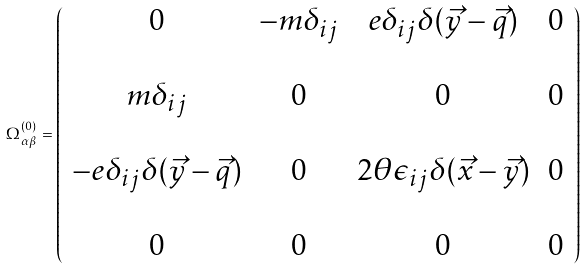Convert formula to latex. <formula><loc_0><loc_0><loc_500><loc_500>\Omega ^ { ( 0 ) } _ { \alpha \beta } = \left ( \begin{array} { c c c c } 0 & - m \delta _ { i j } & e \delta _ { i j } \delta ( \vec { y } - \vec { q } ) & 0 \\ \\ m \delta _ { i j } & 0 & 0 & 0 \\ \\ - e \delta _ { i j } \delta ( \vec { y } - \vec { q } ) & 0 & 2 \theta \epsilon _ { i j } \delta ( \vec { x } - \vec { y } ) & 0 \\ \\ 0 & 0 & 0 & 0 \end{array} \right )</formula> 